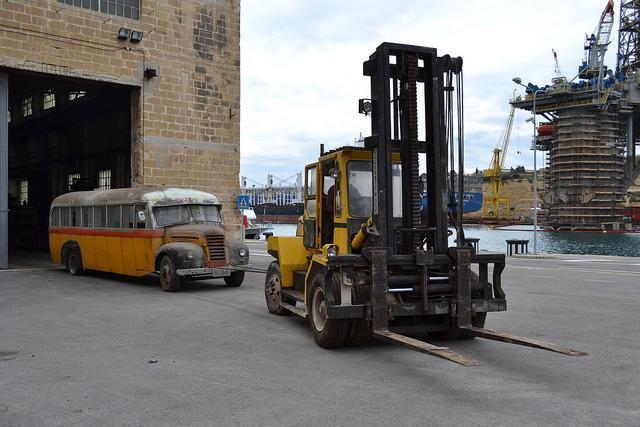How many people are between the two orange buses in the image?
Give a very brief answer. 0. 